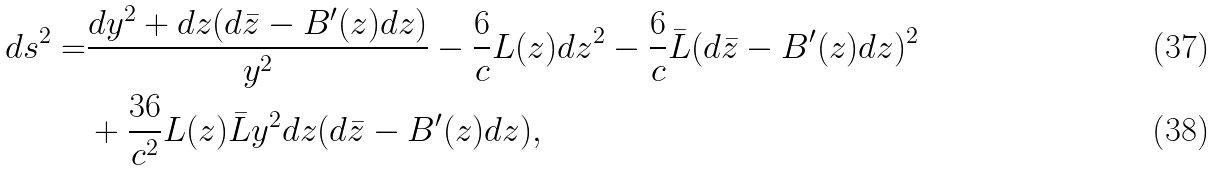<formula> <loc_0><loc_0><loc_500><loc_500>d s ^ { 2 } = & \frac { d y ^ { 2 } + d z ( d \bar { z } - B ^ { \prime } ( z ) d z ) } { y ^ { 2 } } - \frac { 6 } { c } L ( z ) d z ^ { 2 } - \frac { 6 } { c } \bar { L } ( d \bar { z } - B ^ { \prime } ( z ) d z ) ^ { 2 } \\ & + \frac { 3 6 } { c ^ { 2 } } L ( z ) \bar { L } y ^ { 2 } d z ( d \bar { z } - B ^ { \prime } ( z ) d z ) ,</formula> 